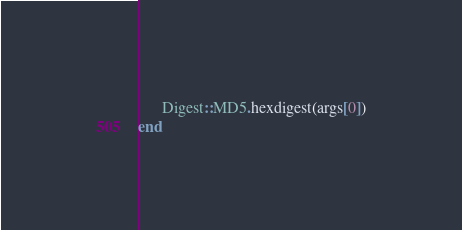Convert code to text. <code><loc_0><loc_0><loc_500><loc_500><_Ruby_>      Digest::MD5.hexdigest(args[0])
end
</code> 